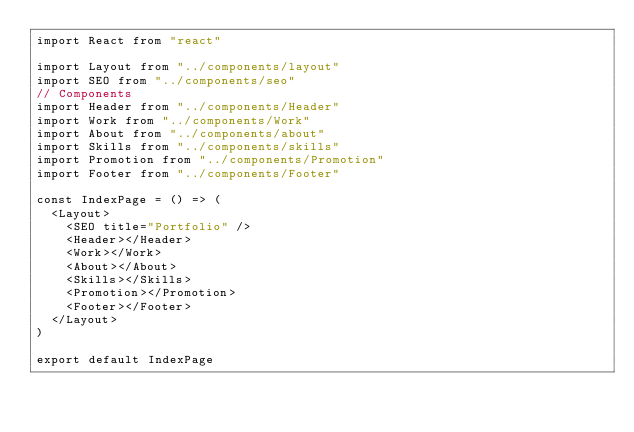Convert code to text. <code><loc_0><loc_0><loc_500><loc_500><_JavaScript_>import React from "react"

import Layout from "../components/layout"
import SEO from "../components/seo"
// Components
import Header from "../components/Header"
import Work from "../components/Work"
import About from "../components/about"
import Skills from "../components/skills"
import Promotion from "../components/Promotion"
import Footer from "../components/Footer"

const IndexPage = () => (
  <Layout>
    <SEO title="Portfolio" />
    <Header></Header>
    <Work></Work>
    <About></About>
    <Skills></Skills>
    <Promotion></Promotion>
    <Footer></Footer>
  </Layout>
)

export default IndexPage
</code> 